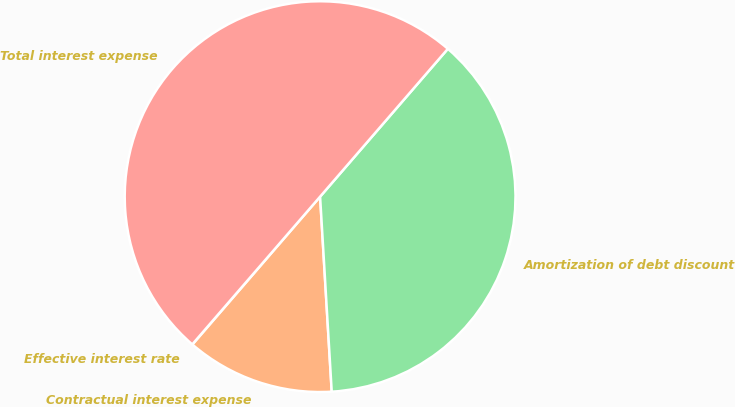Convert chart. <chart><loc_0><loc_0><loc_500><loc_500><pie_chart><fcel>Effective interest rate<fcel>Contractual interest expense<fcel>Amortization of debt discount<fcel>Total interest expense<nl><fcel>0.02%<fcel>12.28%<fcel>37.71%<fcel>49.99%<nl></chart> 